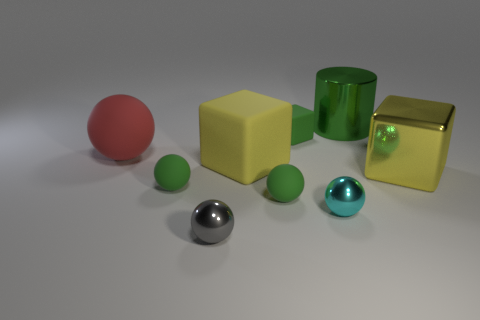Subtract all tiny cyan balls. How many balls are left? 4 Subtract all gray spheres. How many spheres are left? 4 Subtract all blue balls. Subtract all purple cubes. How many balls are left? 5 Add 1 green blocks. How many objects exist? 10 Subtract all cubes. How many objects are left? 6 Add 3 tiny green spheres. How many tiny green spheres are left? 5 Add 3 cyan objects. How many cyan objects exist? 4 Subtract 0 blue blocks. How many objects are left? 9 Subtract all small red metal cubes. Subtract all yellow matte things. How many objects are left? 8 